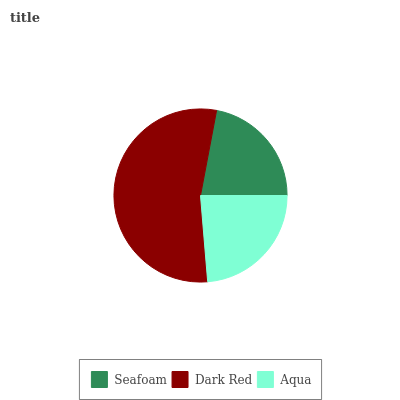Is Seafoam the minimum?
Answer yes or no. Yes. Is Dark Red the maximum?
Answer yes or no. Yes. Is Aqua the minimum?
Answer yes or no. No. Is Aqua the maximum?
Answer yes or no. No. Is Dark Red greater than Aqua?
Answer yes or no. Yes. Is Aqua less than Dark Red?
Answer yes or no. Yes. Is Aqua greater than Dark Red?
Answer yes or no. No. Is Dark Red less than Aqua?
Answer yes or no. No. Is Aqua the high median?
Answer yes or no. Yes. Is Aqua the low median?
Answer yes or no. Yes. Is Seafoam the high median?
Answer yes or no. No. Is Dark Red the low median?
Answer yes or no. No. 